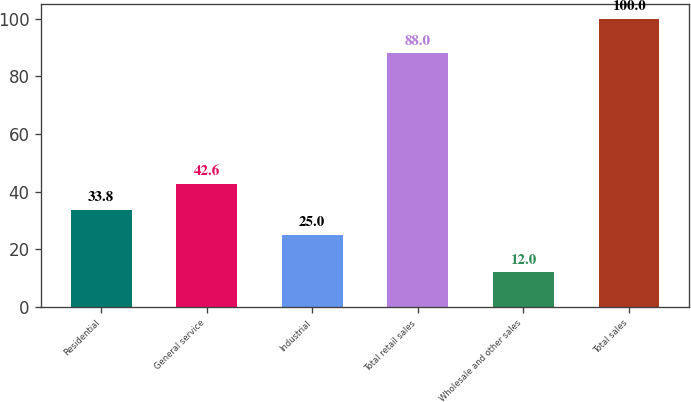<chart> <loc_0><loc_0><loc_500><loc_500><bar_chart><fcel>Residential<fcel>General service<fcel>Industrial<fcel>Total retail sales<fcel>Wholesale and other sales<fcel>Total sales<nl><fcel>33.8<fcel>42.6<fcel>25<fcel>88<fcel>12<fcel>100<nl></chart> 